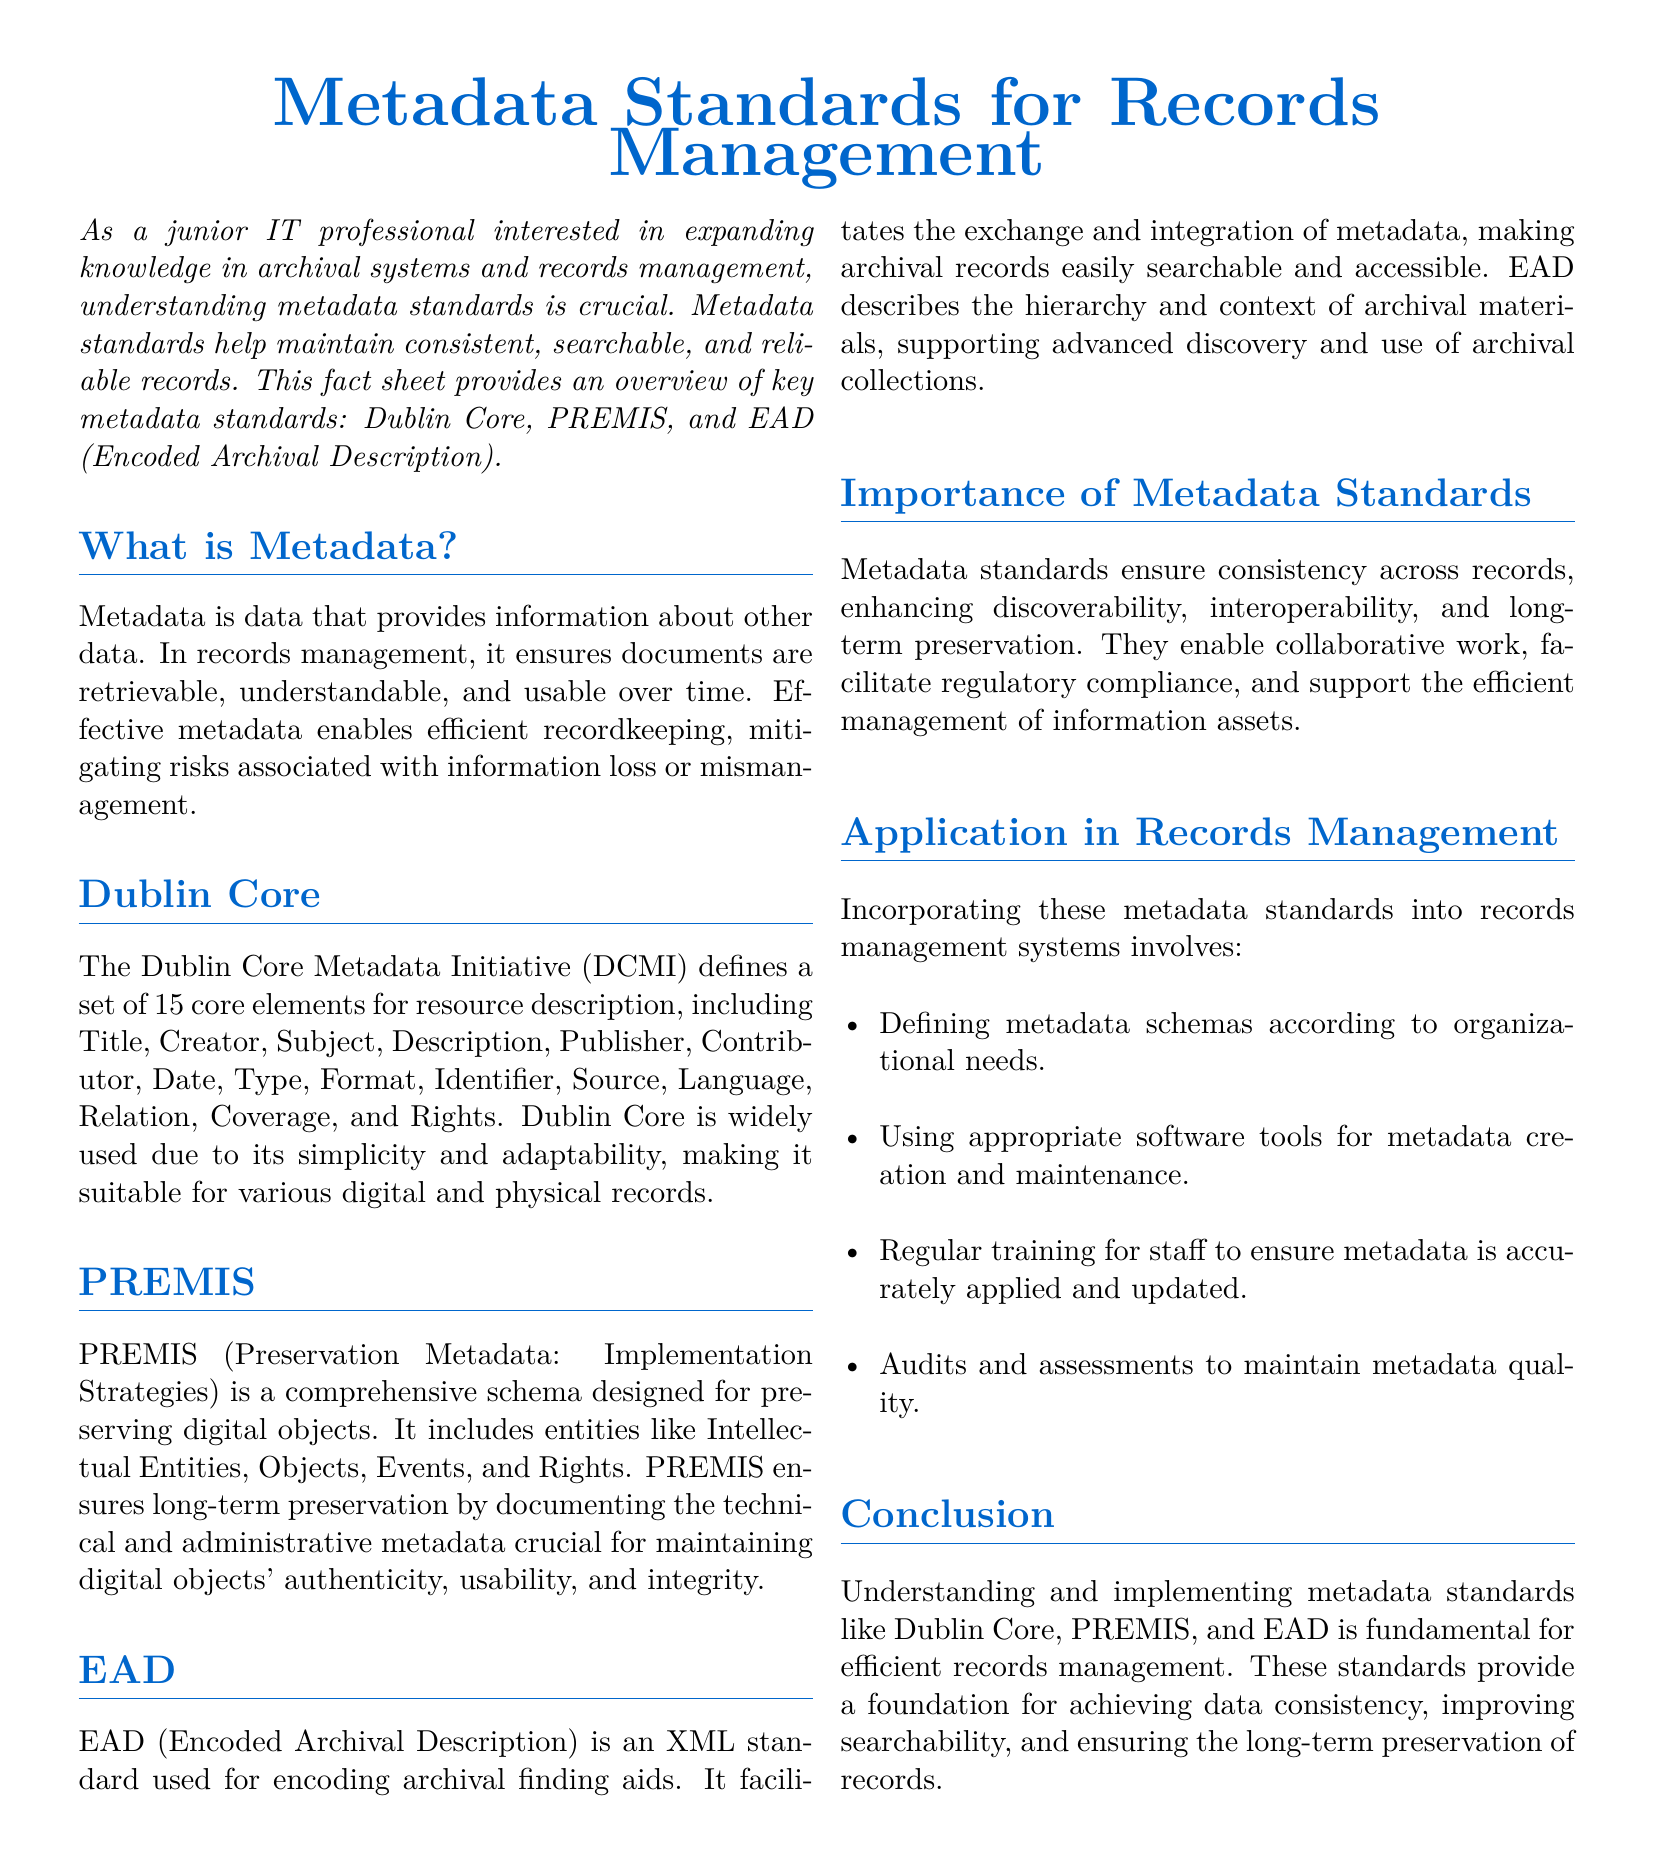What is metadata? Metadata is data that provides information about other data and ensures documents are retrievable and usable over time.
Answer: Data about data How many core elements does Dublin Core define? The document specifies that Dublin Core defines a set of 15 core elements for resource description.
Answer: 15 What does PREMIS stand for? The abbreviation PREMIS refers to Preservation Metadata: Implementation Strategies.
Answer: Preservation Metadata: Implementation Strategies What is EAD used for? EAD is used for encoding archival finding aids, facilitating the exchange and integration of metadata.
Answer: Encoding archival finding aids Name one entity included in PREMIS. The document lists entities like Intellectual Entities, Objects, Events, and Rights as part of PREMIS.
Answer: Intellectual Entities What is one benefit of metadata standards? Metadata standards enhance discoverability, interoperability, and long-term preservation of records.
Answer: Discoverability What is the main purpose of the Dublin Core standard? Dublin Core provides a simple and adaptable framework for describing various digital and physical records.
Answer: Description of resources What should organizations regularly conduct concerning metadata? The document mentions that organizations should perform audits and assessments to maintain metadata quality.
Answer: Audits and assessments What is the main structure used by EAD? EAD uses an XML standard for encoding, which supports advanced discovery and access to archival collections.
Answer: XML standard 